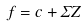<formula> <loc_0><loc_0><loc_500><loc_500>f = c + \Sigma Z</formula> 